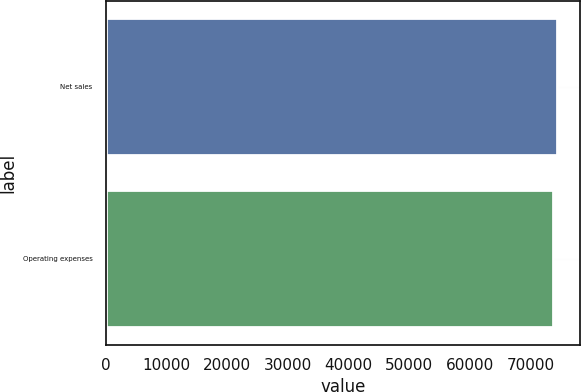Convert chart. <chart><loc_0><loc_0><loc_500><loc_500><bar_chart><fcel>Net sales<fcel>Operating expenses<nl><fcel>74452<fcel>73707<nl></chart> 